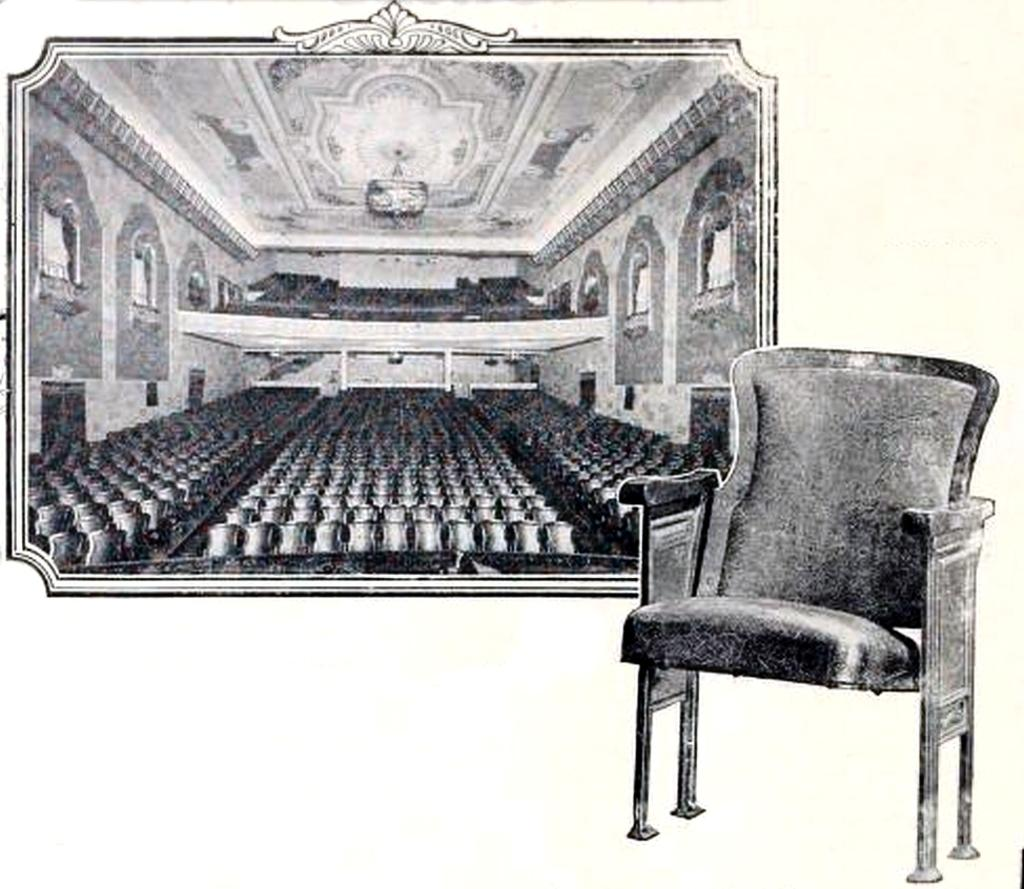What is the color scheme of the image? The image is black and white. What type of furniture can be seen in the image? There are chairs in the image. What is visible in the background of the image? There is a wall in the background of the image. What type of stew is being served in the image? There is no stew present in the image; it is a black and white image featuring chairs and a wall. 